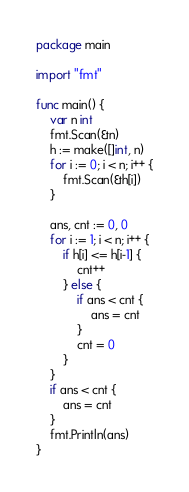<code> <loc_0><loc_0><loc_500><loc_500><_Go_>package main

import "fmt"

func main() {
	var n int
	fmt.Scan(&n)
	h := make([]int, n)
	for i := 0; i < n; i++ {
		fmt.Scan(&h[i])
	}

	ans, cnt := 0, 0
	for i := 1; i < n; i++ {
		if h[i] <= h[i-1] {
			cnt++
		} else {
			if ans < cnt {
				ans = cnt
			}
			cnt = 0
		}
	}
	if ans < cnt {
		ans = cnt
	}
	fmt.Println(ans)
}
</code> 